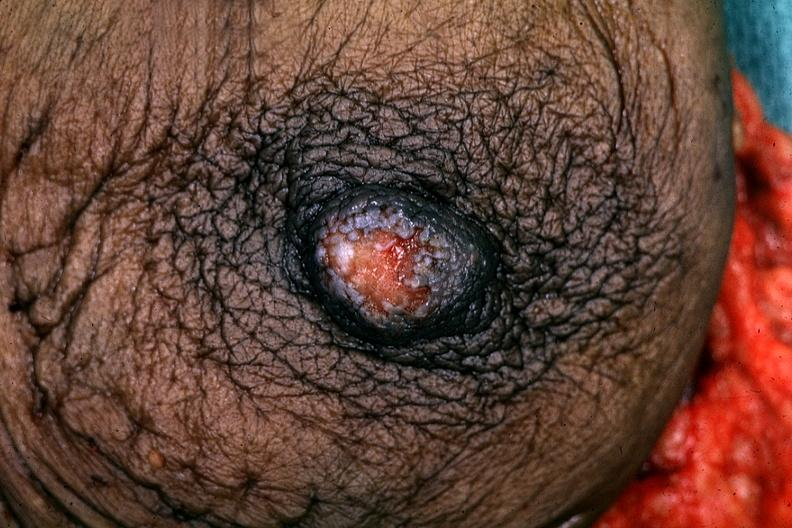what does this image show?
Answer the question using a single word or phrase. Excised breast good example 